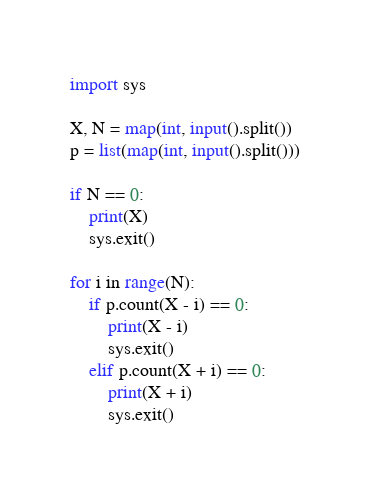<code> <loc_0><loc_0><loc_500><loc_500><_Python_>import sys

X, N = map(int, input().split())
p = list(map(int, input().split()))

if N == 0:
    print(X)
    sys.exit()

for i in range(N):
    if p.count(X - i) == 0:
        print(X - i)
        sys.exit()
    elif p.count(X + i) == 0:
        print(X + i)
        sys.exit()
</code> 